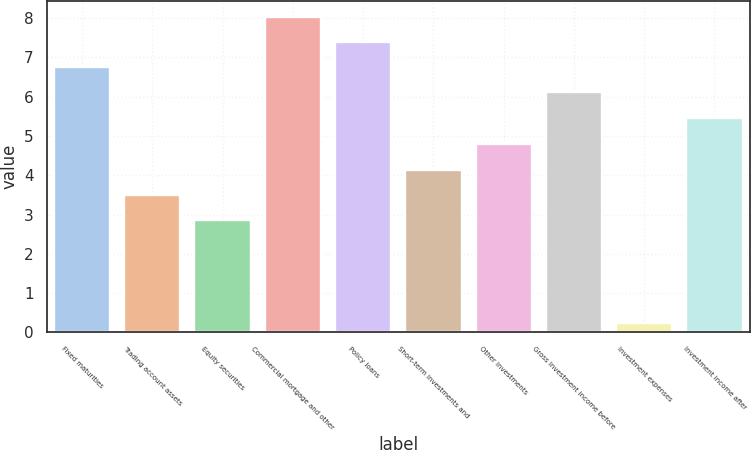Convert chart to OTSL. <chart><loc_0><loc_0><loc_500><loc_500><bar_chart><fcel>Fixed maturities<fcel>Trading account assets<fcel>Equity securities<fcel>Commercial mortgage and other<fcel>Policy loans<fcel>Short-term investments and<fcel>Other investments<fcel>Gross investment income before<fcel>Investment expenses<fcel>Investment income after<nl><fcel>6.76<fcel>3.5<fcel>2.85<fcel>8.04<fcel>7.4<fcel>4.14<fcel>4.79<fcel>6.11<fcel>0.23<fcel>5.46<nl></chart> 